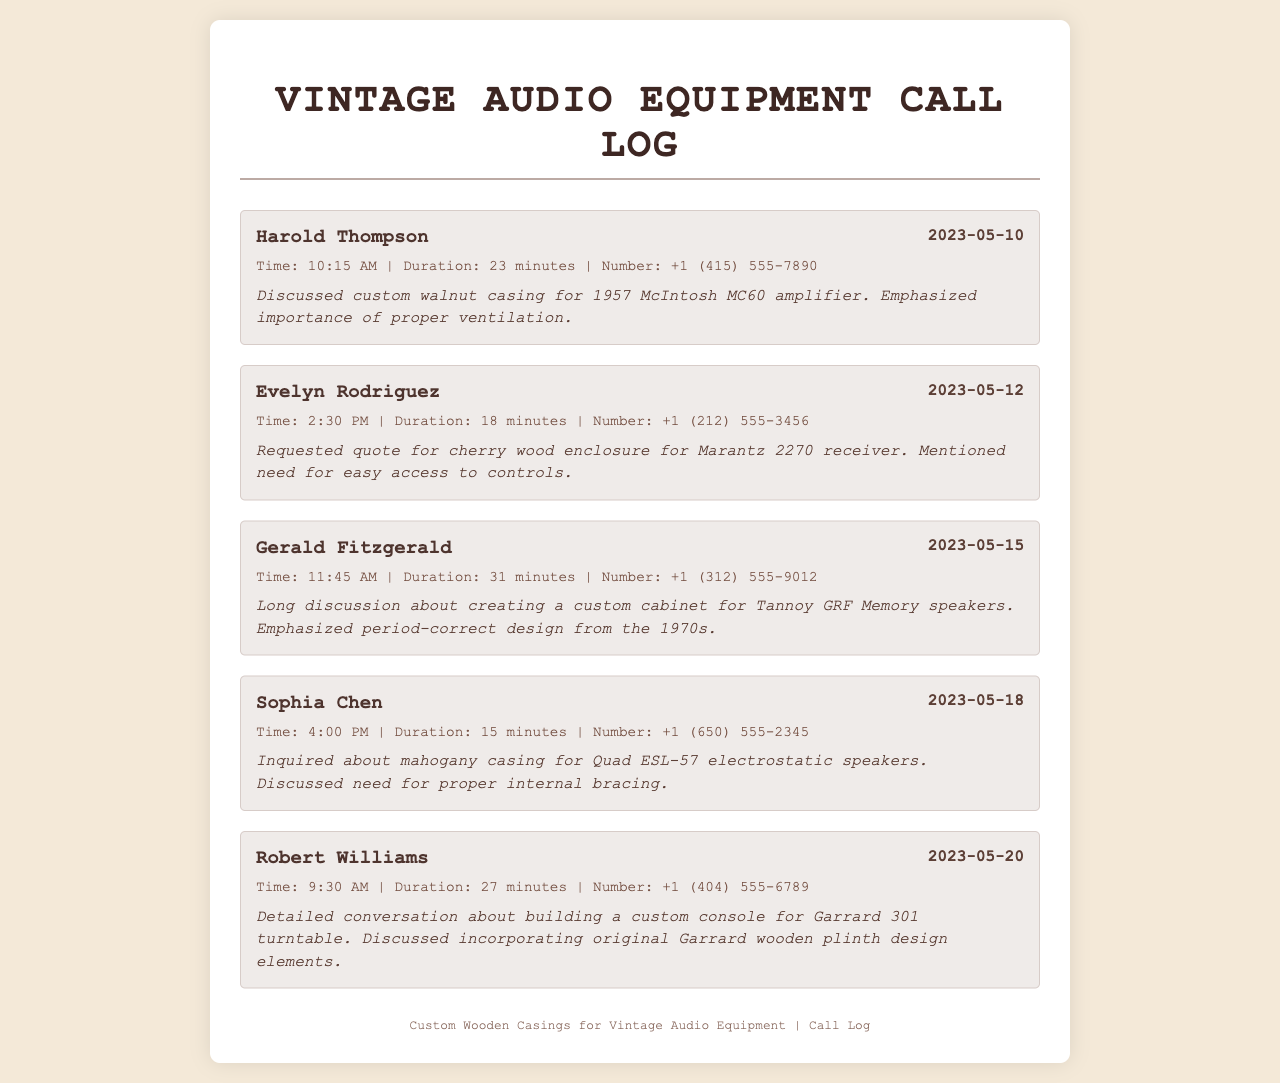What is the date of the first call? The first call in the log is recorded on May 10, 2023.
Answer: May 10, 2023 Who discussed a custom cabinet for Tannoy speakers? Gerald Fitzgerald is the only person mentioned in relation to a custom cabinet for Tannoy GRF Memory speakers.
Answer: Gerald Fitzgerald How long was the call with Evelyn Rodriguez? The duration of the call with Evelyn Rodriguez is mentioned as 18 minutes.
Answer: 18 minutes What type of wood did Sophia Chen inquire about? Sophia Chen asked about a mahogany casing for Quad ESL-57 electrostatic speakers.
Answer: Mahogany Which caller requested a quote for a Marantz 2270 receiver? The caller who requested a quote for the Marantz 2270 receiver is Evelyn Rodriguez.
Answer: Evelyn Rodriguez What time did Robert Williams' call take place? Robert Williams' call is logged at 9:30 AM on May 20, 2023.
Answer: 9:30 AM What was emphasized during the call with Harold Thompson? The importance of proper ventilation was emphasized during the call with Harold Thompson.
Answer: Proper ventilation How many minutes did Gerald Fitzgerald talk for? Gerald Fitzgerald's call lasted for 31 minutes.
Answer: 31 minutes What specific design elements did Robert Williams discuss incorporating? Robert Williams discussed incorporating original Garrard wooden plinth design elements for the Garrard 301 turntable.
Answer: Original Garrard wooden plinth design elements 